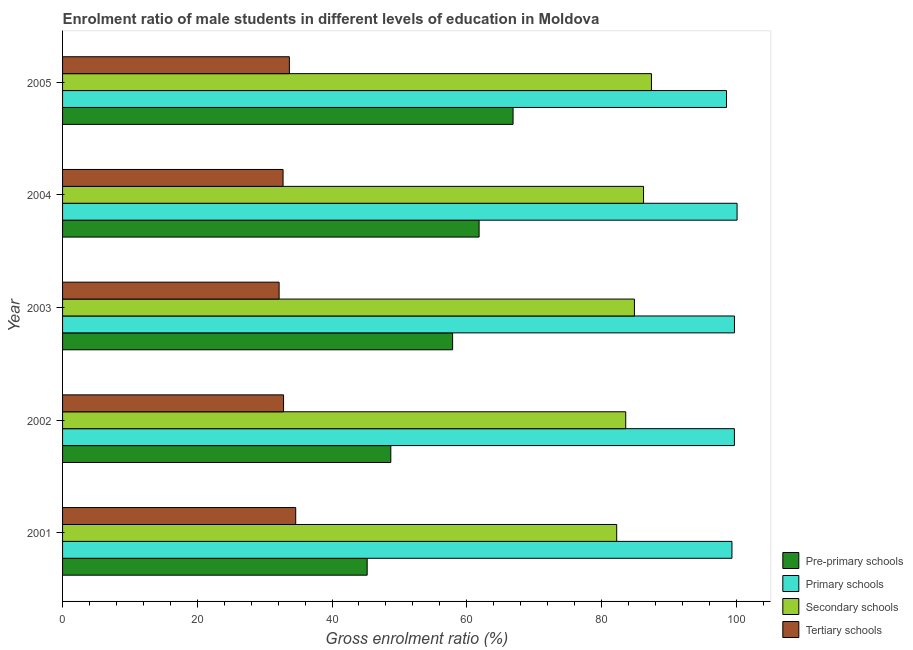How many different coloured bars are there?
Your response must be concise. 4. How many groups of bars are there?
Provide a short and direct response. 5. Are the number of bars per tick equal to the number of legend labels?
Offer a very short reply. Yes. Are the number of bars on each tick of the Y-axis equal?
Your response must be concise. Yes. How many bars are there on the 4th tick from the bottom?
Provide a short and direct response. 4. What is the label of the 1st group of bars from the top?
Keep it short and to the point. 2005. In how many cases, is the number of bars for a given year not equal to the number of legend labels?
Make the answer very short. 0. What is the gross enrolment ratio(female) in pre-primary schools in 2004?
Your answer should be very brief. 61.83. Across all years, what is the maximum gross enrolment ratio(female) in tertiary schools?
Provide a short and direct response. 34.61. Across all years, what is the minimum gross enrolment ratio(female) in primary schools?
Your response must be concise. 98.55. In which year was the gross enrolment ratio(female) in pre-primary schools maximum?
Provide a short and direct response. 2005. In which year was the gross enrolment ratio(female) in tertiary schools minimum?
Ensure brevity in your answer.  2003. What is the total gross enrolment ratio(female) in pre-primary schools in the graph?
Make the answer very short. 280.53. What is the difference between the gross enrolment ratio(female) in pre-primary schools in 2002 and that in 2003?
Provide a short and direct response. -9.17. What is the difference between the gross enrolment ratio(female) in tertiary schools in 2002 and the gross enrolment ratio(female) in primary schools in 2003?
Offer a very short reply. -66.93. What is the average gross enrolment ratio(female) in tertiary schools per year?
Your answer should be compact. 33.19. In the year 2002, what is the difference between the gross enrolment ratio(female) in pre-primary schools and gross enrolment ratio(female) in primary schools?
Your answer should be compact. -51. What is the ratio of the gross enrolment ratio(female) in pre-primary schools in 2002 to that in 2004?
Give a very brief answer. 0.79. What is the difference between the highest and the second highest gross enrolment ratio(female) in tertiary schools?
Your answer should be compact. 0.94. What is the difference between the highest and the lowest gross enrolment ratio(female) in tertiary schools?
Make the answer very short. 2.46. What does the 2nd bar from the top in 2003 represents?
Your response must be concise. Secondary schools. What does the 3rd bar from the bottom in 2002 represents?
Your answer should be very brief. Secondary schools. Is it the case that in every year, the sum of the gross enrolment ratio(female) in pre-primary schools and gross enrolment ratio(female) in primary schools is greater than the gross enrolment ratio(female) in secondary schools?
Make the answer very short. Yes. Where does the legend appear in the graph?
Give a very brief answer. Bottom right. What is the title of the graph?
Your answer should be compact. Enrolment ratio of male students in different levels of education in Moldova. What is the Gross enrolment ratio (%) of Pre-primary schools in 2001?
Provide a short and direct response. 45.21. What is the Gross enrolment ratio (%) in Primary schools in 2001?
Make the answer very short. 99.36. What is the Gross enrolment ratio (%) of Secondary schools in 2001?
Offer a terse response. 82.25. What is the Gross enrolment ratio (%) of Tertiary schools in 2001?
Keep it short and to the point. 34.61. What is the Gross enrolment ratio (%) in Pre-primary schools in 2002?
Give a very brief answer. 48.72. What is the Gross enrolment ratio (%) in Primary schools in 2002?
Give a very brief answer. 99.72. What is the Gross enrolment ratio (%) in Secondary schools in 2002?
Your answer should be compact. 83.59. What is the Gross enrolment ratio (%) in Tertiary schools in 2002?
Keep it short and to the point. 32.8. What is the Gross enrolment ratio (%) of Pre-primary schools in 2003?
Your response must be concise. 57.9. What is the Gross enrolment ratio (%) of Primary schools in 2003?
Provide a short and direct response. 99.73. What is the Gross enrolment ratio (%) in Secondary schools in 2003?
Ensure brevity in your answer.  84.88. What is the Gross enrolment ratio (%) of Tertiary schools in 2003?
Give a very brief answer. 32.14. What is the Gross enrolment ratio (%) of Pre-primary schools in 2004?
Your response must be concise. 61.83. What is the Gross enrolment ratio (%) of Primary schools in 2004?
Give a very brief answer. 100.12. What is the Gross enrolment ratio (%) in Secondary schools in 2004?
Provide a succinct answer. 86.24. What is the Gross enrolment ratio (%) of Tertiary schools in 2004?
Offer a very short reply. 32.73. What is the Gross enrolment ratio (%) of Pre-primary schools in 2005?
Provide a succinct answer. 66.87. What is the Gross enrolment ratio (%) in Primary schools in 2005?
Provide a short and direct response. 98.55. What is the Gross enrolment ratio (%) in Secondary schools in 2005?
Your response must be concise. 87.41. What is the Gross enrolment ratio (%) of Tertiary schools in 2005?
Offer a very short reply. 33.67. Across all years, what is the maximum Gross enrolment ratio (%) in Pre-primary schools?
Your answer should be very brief. 66.87. Across all years, what is the maximum Gross enrolment ratio (%) of Primary schools?
Your answer should be very brief. 100.12. Across all years, what is the maximum Gross enrolment ratio (%) of Secondary schools?
Your response must be concise. 87.41. Across all years, what is the maximum Gross enrolment ratio (%) in Tertiary schools?
Keep it short and to the point. 34.61. Across all years, what is the minimum Gross enrolment ratio (%) in Pre-primary schools?
Your answer should be compact. 45.21. Across all years, what is the minimum Gross enrolment ratio (%) in Primary schools?
Make the answer very short. 98.55. Across all years, what is the minimum Gross enrolment ratio (%) in Secondary schools?
Your answer should be compact. 82.25. Across all years, what is the minimum Gross enrolment ratio (%) of Tertiary schools?
Ensure brevity in your answer.  32.14. What is the total Gross enrolment ratio (%) in Pre-primary schools in the graph?
Ensure brevity in your answer.  280.53. What is the total Gross enrolment ratio (%) of Primary schools in the graph?
Your answer should be very brief. 497.49. What is the total Gross enrolment ratio (%) in Secondary schools in the graph?
Provide a succinct answer. 424.38. What is the total Gross enrolment ratio (%) of Tertiary schools in the graph?
Offer a very short reply. 165.95. What is the difference between the Gross enrolment ratio (%) in Pre-primary schools in 2001 and that in 2002?
Your response must be concise. -3.51. What is the difference between the Gross enrolment ratio (%) in Primary schools in 2001 and that in 2002?
Your response must be concise. -0.36. What is the difference between the Gross enrolment ratio (%) in Secondary schools in 2001 and that in 2002?
Keep it short and to the point. -1.34. What is the difference between the Gross enrolment ratio (%) of Tertiary schools in 2001 and that in 2002?
Your answer should be very brief. 1.8. What is the difference between the Gross enrolment ratio (%) of Pre-primary schools in 2001 and that in 2003?
Provide a short and direct response. -12.68. What is the difference between the Gross enrolment ratio (%) in Primary schools in 2001 and that in 2003?
Give a very brief answer. -0.37. What is the difference between the Gross enrolment ratio (%) of Secondary schools in 2001 and that in 2003?
Ensure brevity in your answer.  -2.63. What is the difference between the Gross enrolment ratio (%) of Tertiary schools in 2001 and that in 2003?
Your response must be concise. 2.46. What is the difference between the Gross enrolment ratio (%) in Pre-primary schools in 2001 and that in 2004?
Provide a succinct answer. -16.61. What is the difference between the Gross enrolment ratio (%) in Primary schools in 2001 and that in 2004?
Your answer should be very brief. -0.76. What is the difference between the Gross enrolment ratio (%) in Secondary schools in 2001 and that in 2004?
Make the answer very short. -3.99. What is the difference between the Gross enrolment ratio (%) in Tertiary schools in 2001 and that in 2004?
Provide a short and direct response. 1.88. What is the difference between the Gross enrolment ratio (%) in Pre-primary schools in 2001 and that in 2005?
Offer a terse response. -21.66. What is the difference between the Gross enrolment ratio (%) of Primary schools in 2001 and that in 2005?
Give a very brief answer. 0.81. What is the difference between the Gross enrolment ratio (%) in Secondary schools in 2001 and that in 2005?
Your answer should be very brief. -5.16. What is the difference between the Gross enrolment ratio (%) of Tertiary schools in 2001 and that in 2005?
Offer a terse response. 0.94. What is the difference between the Gross enrolment ratio (%) in Pre-primary schools in 2002 and that in 2003?
Keep it short and to the point. -9.17. What is the difference between the Gross enrolment ratio (%) of Primary schools in 2002 and that in 2003?
Offer a terse response. -0.01. What is the difference between the Gross enrolment ratio (%) of Secondary schools in 2002 and that in 2003?
Provide a succinct answer. -1.29. What is the difference between the Gross enrolment ratio (%) in Tertiary schools in 2002 and that in 2003?
Keep it short and to the point. 0.66. What is the difference between the Gross enrolment ratio (%) of Pre-primary schools in 2002 and that in 2004?
Give a very brief answer. -13.11. What is the difference between the Gross enrolment ratio (%) in Primary schools in 2002 and that in 2004?
Keep it short and to the point. -0.4. What is the difference between the Gross enrolment ratio (%) in Secondary schools in 2002 and that in 2004?
Ensure brevity in your answer.  -2.64. What is the difference between the Gross enrolment ratio (%) of Tertiary schools in 2002 and that in 2004?
Offer a very short reply. 0.07. What is the difference between the Gross enrolment ratio (%) in Pre-primary schools in 2002 and that in 2005?
Your response must be concise. -18.15. What is the difference between the Gross enrolment ratio (%) of Primary schools in 2002 and that in 2005?
Offer a terse response. 1.17. What is the difference between the Gross enrolment ratio (%) of Secondary schools in 2002 and that in 2005?
Provide a short and direct response. -3.82. What is the difference between the Gross enrolment ratio (%) in Tertiary schools in 2002 and that in 2005?
Ensure brevity in your answer.  -0.86. What is the difference between the Gross enrolment ratio (%) of Pre-primary schools in 2003 and that in 2004?
Provide a short and direct response. -3.93. What is the difference between the Gross enrolment ratio (%) in Primary schools in 2003 and that in 2004?
Give a very brief answer. -0.39. What is the difference between the Gross enrolment ratio (%) of Secondary schools in 2003 and that in 2004?
Your response must be concise. -1.35. What is the difference between the Gross enrolment ratio (%) in Tertiary schools in 2003 and that in 2004?
Keep it short and to the point. -0.59. What is the difference between the Gross enrolment ratio (%) of Pre-primary schools in 2003 and that in 2005?
Give a very brief answer. -8.97. What is the difference between the Gross enrolment ratio (%) in Primary schools in 2003 and that in 2005?
Provide a short and direct response. 1.18. What is the difference between the Gross enrolment ratio (%) of Secondary schools in 2003 and that in 2005?
Give a very brief answer. -2.53. What is the difference between the Gross enrolment ratio (%) in Tertiary schools in 2003 and that in 2005?
Give a very brief answer. -1.52. What is the difference between the Gross enrolment ratio (%) in Pre-primary schools in 2004 and that in 2005?
Provide a short and direct response. -5.04. What is the difference between the Gross enrolment ratio (%) in Primary schools in 2004 and that in 2005?
Offer a terse response. 1.57. What is the difference between the Gross enrolment ratio (%) of Secondary schools in 2004 and that in 2005?
Ensure brevity in your answer.  -1.17. What is the difference between the Gross enrolment ratio (%) in Tertiary schools in 2004 and that in 2005?
Give a very brief answer. -0.94. What is the difference between the Gross enrolment ratio (%) of Pre-primary schools in 2001 and the Gross enrolment ratio (%) of Primary schools in 2002?
Offer a very short reply. -54.51. What is the difference between the Gross enrolment ratio (%) in Pre-primary schools in 2001 and the Gross enrolment ratio (%) in Secondary schools in 2002?
Provide a succinct answer. -38.38. What is the difference between the Gross enrolment ratio (%) in Pre-primary schools in 2001 and the Gross enrolment ratio (%) in Tertiary schools in 2002?
Your answer should be compact. 12.41. What is the difference between the Gross enrolment ratio (%) in Primary schools in 2001 and the Gross enrolment ratio (%) in Secondary schools in 2002?
Make the answer very short. 15.77. What is the difference between the Gross enrolment ratio (%) of Primary schools in 2001 and the Gross enrolment ratio (%) of Tertiary schools in 2002?
Your response must be concise. 66.56. What is the difference between the Gross enrolment ratio (%) in Secondary schools in 2001 and the Gross enrolment ratio (%) in Tertiary schools in 2002?
Your answer should be very brief. 49.45. What is the difference between the Gross enrolment ratio (%) in Pre-primary schools in 2001 and the Gross enrolment ratio (%) in Primary schools in 2003?
Offer a terse response. -54.52. What is the difference between the Gross enrolment ratio (%) of Pre-primary schools in 2001 and the Gross enrolment ratio (%) of Secondary schools in 2003?
Your response must be concise. -39.67. What is the difference between the Gross enrolment ratio (%) of Pre-primary schools in 2001 and the Gross enrolment ratio (%) of Tertiary schools in 2003?
Provide a succinct answer. 13.07. What is the difference between the Gross enrolment ratio (%) in Primary schools in 2001 and the Gross enrolment ratio (%) in Secondary schools in 2003?
Ensure brevity in your answer.  14.48. What is the difference between the Gross enrolment ratio (%) of Primary schools in 2001 and the Gross enrolment ratio (%) of Tertiary schools in 2003?
Offer a terse response. 67.22. What is the difference between the Gross enrolment ratio (%) of Secondary schools in 2001 and the Gross enrolment ratio (%) of Tertiary schools in 2003?
Offer a very short reply. 50.11. What is the difference between the Gross enrolment ratio (%) of Pre-primary schools in 2001 and the Gross enrolment ratio (%) of Primary schools in 2004?
Provide a succinct answer. -54.91. What is the difference between the Gross enrolment ratio (%) of Pre-primary schools in 2001 and the Gross enrolment ratio (%) of Secondary schools in 2004?
Give a very brief answer. -41.02. What is the difference between the Gross enrolment ratio (%) of Pre-primary schools in 2001 and the Gross enrolment ratio (%) of Tertiary schools in 2004?
Provide a short and direct response. 12.48. What is the difference between the Gross enrolment ratio (%) in Primary schools in 2001 and the Gross enrolment ratio (%) in Secondary schools in 2004?
Your answer should be very brief. 13.12. What is the difference between the Gross enrolment ratio (%) in Primary schools in 2001 and the Gross enrolment ratio (%) in Tertiary schools in 2004?
Give a very brief answer. 66.63. What is the difference between the Gross enrolment ratio (%) in Secondary schools in 2001 and the Gross enrolment ratio (%) in Tertiary schools in 2004?
Ensure brevity in your answer.  49.52. What is the difference between the Gross enrolment ratio (%) in Pre-primary schools in 2001 and the Gross enrolment ratio (%) in Primary schools in 2005?
Make the answer very short. -53.34. What is the difference between the Gross enrolment ratio (%) of Pre-primary schools in 2001 and the Gross enrolment ratio (%) of Secondary schools in 2005?
Your response must be concise. -42.2. What is the difference between the Gross enrolment ratio (%) in Pre-primary schools in 2001 and the Gross enrolment ratio (%) in Tertiary schools in 2005?
Ensure brevity in your answer.  11.55. What is the difference between the Gross enrolment ratio (%) of Primary schools in 2001 and the Gross enrolment ratio (%) of Secondary schools in 2005?
Your answer should be compact. 11.95. What is the difference between the Gross enrolment ratio (%) in Primary schools in 2001 and the Gross enrolment ratio (%) in Tertiary schools in 2005?
Offer a terse response. 65.69. What is the difference between the Gross enrolment ratio (%) in Secondary schools in 2001 and the Gross enrolment ratio (%) in Tertiary schools in 2005?
Keep it short and to the point. 48.59. What is the difference between the Gross enrolment ratio (%) of Pre-primary schools in 2002 and the Gross enrolment ratio (%) of Primary schools in 2003?
Provide a succinct answer. -51.01. What is the difference between the Gross enrolment ratio (%) of Pre-primary schools in 2002 and the Gross enrolment ratio (%) of Secondary schools in 2003?
Offer a very short reply. -36.16. What is the difference between the Gross enrolment ratio (%) of Pre-primary schools in 2002 and the Gross enrolment ratio (%) of Tertiary schools in 2003?
Offer a very short reply. 16.58. What is the difference between the Gross enrolment ratio (%) of Primary schools in 2002 and the Gross enrolment ratio (%) of Secondary schools in 2003?
Offer a very short reply. 14.84. What is the difference between the Gross enrolment ratio (%) in Primary schools in 2002 and the Gross enrolment ratio (%) in Tertiary schools in 2003?
Provide a succinct answer. 67.58. What is the difference between the Gross enrolment ratio (%) in Secondary schools in 2002 and the Gross enrolment ratio (%) in Tertiary schools in 2003?
Keep it short and to the point. 51.45. What is the difference between the Gross enrolment ratio (%) of Pre-primary schools in 2002 and the Gross enrolment ratio (%) of Primary schools in 2004?
Provide a succinct answer. -51.4. What is the difference between the Gross enrolment ratio (%) in Pre-primary schools in 2002 and the Gross enrolment ratio (%) in Secondary schools in 2004?
Ensure brevity in your answer.  -37.52. What is the difference between the Gross enrolment ratio (%) of Pre-primary schools in 2002 and the Gross enrolment ratio (%) of Tertiary schools in 2004?
Keep it short and to the point. 15.99. What is the difference between the Gross enrolment ratio (%) in Primary schools in 2002 and the Gross enrolment ratio (%) in Secondary schools in 2004?
Offer a very short reply. 13.48. What is the difference between the Gross enrolment ratio (%) in Primary schools in 2002 and the Gross enrolment ratio (%) in Tertiary schools in 2004?
Give a very brief answer. 66.99. What is the difference between the Gross enrolment ratio (%) in Secondary schools in 2002 and the Gross enrolment ratio (%) in Tertiary schools in 2004?
Provide a short and direct response. 50.86. What is the difference between the Gross enrolment ratio (%) in Pre-primary schools in 2002 and the Gross enrolment ratio (%) in Primary schools in 2005?
Ensure brevity in your answer.  -49.83. What is the difference between the Gross enrolment ratio (%) of Pre-primary schools in 2002 and the Gross enrolment ratio (%) of Secondary schools in 2005?
Keep it short and to the point. -38.69. What is the difference between the Gross enrolment ratio (%) of Pre-primary schools in 2002 and the Gross enrolment ratio (%) of Tertiary schools in 2005?
Make the answer very short. 15.06. What is the difference between the Gross enrolment ratio (%) of Primary schools in 2002 and the Gross enrolment ratio (%) of Secondary schools in 2005?
Ensure brevity in your answer.  12.31. What is the difference between the Gross enrolment ratio (%) in Primary schools in 2002 and the Gross enrolment ratio (%) in Tertiary schools in 2005?
Give a very brief answer. 66.06. What is the difference between the Gross enrolment ratio (%) in Secondary schools in 2002 and the Gross enrolment ratio (%) in Tertiary schools in 2005?
Keep it short and to the point. 49.93. What is the difference between the Gross enrolment ratio (%) in Pre-primary schools in 2003 and the Gross enrolment ratio (%) in Primary schools in 2004?
Your answer should be very brief. -42.23. What is the difference between the Gross enrolment ratio (%) in Pre-primary schools in 2003 and the Gross enrolment ratio (%) in Secondary schools in 2004?
Provide a short and direct response. -28.34. What is the difference between the Gross enrolment ratio (%) in Pre-primary schools in 2003 and the Gross enrolment ratio (%) in Tertiary schools in 2004?
Your answer should be very brief. 25.17. What is the difference between the Gross enrolment ratio (%) of Primary schools in 2003 and the Gross enrolment ratio (%) of Secondary schools in 2004?
Offer a very short reply. 13.49. What is the difference between the Gross enrolment ratio (%) of Primary schools in 2003 and the Gross enrolment ratio (%) of Tertiary schools in 2004?
Ensure brevity in your answer.  67. What is the difference between the Gross enrolment ratio (%) in Secondary schools in 2003 and the Gross enrolment ratio (%) in Tertiary schools in 2004?
Your answer should be very brief. 52.15. What is the difference between the Gross enrolment ratio (%) in Pre-primary schools in 2003 and the Gross enrolment ratio (%) in Primary schools in 2005?
Keep it short and to the point. -40.66. What is the difference between the Gross enrolment ratio (%) of Pre-primary schools in 2003 and the Gross enrolment ratio (%) of Secondary schools in 2005?
Provide a succinct answer. -29.52. What is the difference between the Gross enrolment ratio (%) in Pre-primary schools in 2003 and the Gross enrolment ratio (%) in Tertiary schools in 2005?
Ensure brevity in your answer.  24.23. What is the difference between the Gross enrolment ratio (%) in Primary schools in 2003 and the Gross enrolment ratio (%) in Secondary schools in 2005?
Give a very brief answer. 12.32. What is the difference between the Gross enrolment ratio (%) of Primary schools in 2003 and the Gross enrolment ratio (%) of Tertiary schools in 2005?
Ensure brevity in your answer.  66.06. What is the difference between the Gross enrolment ratio (%) in Secondary schools in 2003 and the Gross enrolment ratio (%) in Tertiary schools in 2005?
Offer a very short reply. 51.22. What is the difference between the Gross enrolment ratio (%) in Pre-primary schools in 2004 and the Gross enrolment ratio (%) in Primary schools in 2005?
Provide a succinct answer. -36.73. What is the difference between the Gross enrolment ratio (%) in Pre-primary schools in 2004 and the Gross enrolment ratio (%) in Secondary schools in 2005?
Your answer should be very brief. -25.58. What is the difference between the Gross enrolment ratio (%) in Pre-primary schools in 2004 and the Gross enrolment ratio (%) in Tertiary schools in 2005?
Offer a very short reply. 28.16. What is the difference between the Gross enrolment ratio (%) of Primary schools in 2004 and the Gross enrolment ratio (%) of Secondary schools in 2005?
Your answer should be very brief. 12.71. What is the difference between the Gross enrolment ratio (%) of Primary schools in 2004 and the Gross enrolment ratio (%) of Tertiary schools in 2005?
Ensure brevity in your answer.  66.45. What is the difference between the Gross enrolment ratio (%) in Secondary schools in 2004 and the Gross enrolment ratio (%) in Tertiary schools in 2005?
Your answer should be very brief. 52.57. What is the average Gross enrolment ratio (%) in Pre-primary schools per year?
Your answer should be very brief. 56.11. What is the average Gross enrolment ratio (%) of Primary schools per year?
Offer a terse response. 99.5. What is the average Gross enrolment ratio (%) in Secondary schools per year?
Ensure brevity in your answer.  84.88. What is the average Gross enrolment ratio (%) in Tertiary schools per year?
Offer a very short reply. 33.19. In the year 2001, what is the difference between the Gross enrolment ratio (%) in Pre-primary schools and Gross enrolment ratio (%) in Primary schools?
Provide a short and direct response. -54.15. In the year 2001, what is the difference between the Gross enrolment ratio (%) of Pre-primary schools and Gross enrolment ratio (%) of Secondary schools?
Ensure brevity in your answer.  -37.04. In the year 2001, what is the difference between the Gross enrolment ratio (%) of Pre-primary schools and Gross enrolment ratio (%) of Tertiary schools?
Provide a short and direct response. 10.61. In the year 2001, what is the difference between the Gross enrolment ratio (%) of Primary schools and Gross enrolment ratio (%) of Secondary schools?
Give a very brief answer. 17.11. In the year 2001, what is the difference between the Gross enrolment ratio (%) of Primary schools and Gross enrolment ratio (%) of Tertiary schools?
Make the answer very short. 64.75. In the year 2001, what is the difference between the Gross enrolment ratio (%) of Secondary schools and Gross enrolment ratio (%) of Tertiary schools?
Your response must be concise. 47.64. In the year 2002, what is the difference between the Gross enrolment ratio (%) of Pre-primary schools and Gross enrolment ratio (%) of Primary schools?
Give a very brief answer. -51. In the year 2002, what is the difference between the Gross enrolment ratio (%) of Pre-primary schools and Gross enrolment ratio (%) of Secondary schools?
Offer a terse response. -34.87. In the year 2002, what is the difference between the Gross enrolment ratio (%) in Pre-primary schools and Gross enrolment ratio (%) in Tertiary schools?
Keep it short and to the point. 15.92. In the year 2002, what is the difference between the Gross enrolment ratio (%) of Primary schools and Gross enrolment ratio (%) of Secondary schools?
Give a very brief answer. 16.13. In the year 2002, what is the difference between the Gross enrolment ratio (%) of Primary schools and Gross enrolment ratio (%) of Tertiary schools?
Your answer should be compact. 66.92. In the year 2002, what is the difference between the Gross enrolment ratio (%) of Secondary schools and Gross enrolment ratio (%) of Tertiary schools?
Ensure brevity in your answer.  50.79. In the year 2003, what is the difference between the Gross enrolment ratio (%) of Pre-primary schools and Gross enrolment ratio (%) of Primary schools?
Your response must be concise. -41.84. In the year 2003, what is the difference between the Gross enrolment ratio (%) in Pre-primary schools and Gross enrolment ratio (%) in Secondary schools?
Your answer should be very brief. -26.99. In the year 2003, what is the difference between the Gross enrolment ratio (%) of Pre-primary schools and Gross enrolment ratio (%) of Tertiary schools?
Your answer should be very brief. 25.75. In the year 2003, what is the difference between the Gross enrolment ratio (%) of Primary schools and Gross enrolment ratio (%) of Secondary schools?
Your response must be concise. 14.85. In the year 2003, what is the difference between the Gross enrolment ratio (%) of Primary schools and Gross enrolment ratio (%) of Tertiary schools?
Offer a very short reply. 67.59. In the year 2003, what is the difference between the Gross enrolment ratio (%) in Secondary schools and Gross enrolment ratio (%) in Tertiary schools?
Provide a succinct answer. 52.74. In the year 2004, what is the difference between the Gross enrolment ratio (%) of Pre-primary schools and Gross enrolment ratio (%) of Primary schools?
Give a very brief answer. -38.29. In the year 2004, what is the difference between the Gross enrolment ratio (%) in Pre-primary schools and Gross enrolment ratio (%) in Secondary schools?
Offer a very short reply. -24.41. In the year 2004, what is the difference between the Gross enrolment ratio (%) of Pre-primary schools and Gross enrolment ratio (%) of Tertiary schools?
Your answer should be very brief. 29.1. In the year 2004, what is the difference between the Gross enrolment ratio (%) of Primary schools and Gross enrolment ratio (%) of Secondary schools?
Offer a terse response. 13.88. In the year 2004, what is the difference between the Gross enrolment ratio (%) in Primary schools and Gross enrolment ratio (%) in Tertiary schools?
Keep it short and to the point. 67.39. In the year 2004, what is the difference between the Gross enrolment ratio (%) in Secondary schools and Gross enrolment ratio (%) in Tertiary schools?
Offer a very short reply. 53.51. In the year 2005, what is the difference between the Gross enrolment ratio (%) in Pre-primary schools and Gross enrolment ratio (%) in Primary schools?
Ensure brevity in your answer.  -31.68. In the year 2005, what is the difference between the Gross enrolment ratio (%) in Pre-primary schools and Gross enrolment ratio (%) in Secondary schools?
Provide a short and direct response. -20.54. In the year 2005, what is the difference between the Gross enrolment ratio (%) in Pre-primary schools and Gross enrolment ratio (%) in Tertiary schools?
Offer a terse response. 33.2. In the year 2005, what is the difference between the Gross enrolment ratio (%) of Primary schools and Gross enrolment ratio (%) of Secondary schools?
Provide a short and direct response. 11.14. In the year 2005, what is the difference between the Gross enrolment ratio (%) in Primary schools and Gross enrolment ratio (%) in Tertiary schools?
Your response must be concise. 64.89. In the year 2005, what is the difference between the Gross enrolment ratio (%) of Secondary schools and Gross enrolment ratio (%) of Tertiary schools?
Your answer should be compact. 53.74. What is the ratio of the Gross enrolment ratio (%) in Pre-primary schools in 2001 to that in 2002?
Keep it short and to the point. 0.93. What is the ratio of the Gross enrolment ratio (%) in Primary schools in 2001 to that in 2002?
Keep it short and to the point. 1. What is the ratio of the Gross enrolment ratio (%) of Tertiary schools in 2001 to that in 2002?
Give a very brief answer. 1.05. What is the ratio of the Gross enrolment ratio (%) of Pre-primary schools in 2001 to that in 2003?
Your response must be concise. 0.78. What is the ratio of the Gross enrolment ratio (%) in Primary schools in 2001 to that in 2003?
Ensure brevity in your answer.  1. What is the ratio of the Gross enrolment ratio (%) in Secondary schools in 2001 to that in 2003?
Keep it short and to the point. 0.97. What is the ratio of the Gross enrolment ratio (%) of Tertiary schools in 2001 to that in 2003?
Provide a succinct answer. 1.08. What is the ratio of the Gross enrolment ratio (%) in Pre-primary schools in 2001 to that in 2004?
Make the answer very short. 0.73. What is the ratio of the Gross enrolment ratio (%) in Secondary schools in 2001 to that in 2004?
Your response must be concise. 0.95. What is the ratio of the Gross enrolment ratio (%) of Tertiary schools in 2001 to that in 2004?
Ensure brevity in your answer.  1.06. What is the ratio of the Gross enrolment ratio (%) in Pre-primary schools in 2001 to that in 2005?
Give a very brief answer. 0.68. What is the ratio of the Gross enrolment ratio (%) in Primary schools in 2001 to that in 2005?
Make the answer very short. 1.01. What is the ratio of the Gross enrolment ratio (%) of Secondary schools in 2001 to that in 2005?
Make the answer very short. 0.94. What is the ratio of the Gross enrolment ratio (%) in Tertiary schools in 2001 to that in 2005?
Offer a very short reply. 1.03. What is the ratio of the Gross enrolment ratio (%) in Pre-primary schools in 2002 to that in 2003?
Offer a terse response. 0.84. What is the ratio of the Gross enrolment ratio (%) in Secondary schools in 2002 to that in 2003?
Provide a short and direct response. 0.98. What is the ratio of the Gross enrolment ratio (%) in Tertiary schools in 2002 to that in 2003?
Keep it short and to the point. 1.02. What is the ratio of the Gross enrolment ratio (%) in Pre-primary schools in 2002 to that in 2004?
Give a very brief answer. 0.79. What is the ratio of the Gross enrolment ratio (%) of Primary schools in 2002 to that in 2004?
Your response must be concise. 1. What is the ratio of the Gross enrolment ratio (%) of Secondary schools in 2002 to that in 2004?
Provide a succinct answer. 0.97. What is the ratio of the Gross enrolment ratio (%) of Pre-primary schools in 2002 to that in 2005?
Make the answer very short. 0.73. What is the ratio of the Gross enrolment ratio (%) of Primary schools in 2002 to that in 2005?
Provide a succinct answer. 1.01. What is the ratio of the Gross enrolment ratio (%) in Secondary schools in 2002 to that in 2005?
Provide a succinct answer. 0.96. What is the ratio of the Gross enrolment ratio (%) in Tertiary schools in 2002 to that in 2005?
Offer a terse response. 0.97. What is the ratio of the Gross enrolment ratio (%) of Pre-primary schools in 2003 to that in 2004?
Your answer should be very brief. 0.94. What is the ratio of the Gross enrolment ratio (%) in Primary schools in 2003 to that in 2004?
Your answer should be very brief. 1. What is the ratio of the Gross enrolment ratio (%) of Secondary schools in 2003 to that in 2004?
Keep it short and to the point. 0.98. What is the ratio of the Gross enrolment ratio (%) in Tertiary schools in 2003 to that in 2004?
Offer a very short reply. 0.98. What is the ratio of the Gross enrolment ratio (%) of Pre-primary schools in 2003 to that in 2005?
Your answer should be very brief. 0.87. What is the ratio of the Gross enrolment ratio (%) of Secondary schools in 2003 to that in 2005?
Your answer should be compact. 0.97. What is the ratio of the Gross enrolment ratio (%) of Tertiary schools in 2003 to that in 2005?
Provide a short and direct response. 0.95. What is the ratio of the Gross enrolment ratio (%) in Pre-primary schools in 2004 to that in 2005?
Ensure brevity in your answer.  0.92. What is the ratio of the Gross enrolment ratio (%) in Primary schools in 2004 to that in 2005?
Offer a very short reply. 1.02. What is the ratio of the Gross enrolment ratio (%) in Secondary schools in 2004 to that in 2005?
Make the answer very short. 0.99. What is the ratio of the Gross enrolment ratio (%) in Tertiary schools in 2004 to that in 2005?
Your answer should be very brief. 0.97. What is the difference between the highest and the second highest Gross enrolment ratio (%) of Pre-primary schools?
Your response must be concise. 5.04. What is the difference between the highest and the second highest Gross enrolment ratio (%) in Primary schools?
Give a very brief answer. 0.39. What is the difference between the highest and the second highest Gross enrolment ratio (%) of Secondary schools?
Your answer should be very brief. 1.17. What is the difference between the highest and the second highest Gross enrolment ratio (%) in Tertiary schools?
Provide a succinct answer. 0.94. What is the difference between the highest and the lowest Gross enrolment ratio (%) in Pre-primary schools?
Keep it short and to the point. 21.66. What is the difference between the highest and the lowest Gross enrolment ratio (%) in Primary schools?
Provide a succinct answer. 1.57. What is the difference between the highest and the lowest Gross enrolment ratio (%) of Secondary schools?
Ensure brevity in your answer.  5.16. What is the difference between the highest and the lowest Gross enrolment ratio (%) of Tertiary schools?
Offer a terse response. 2.46. 